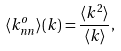Convert formula to latex. <formula><loc_0><loc_0><loc_500><loc_500>\langle k _ { n n } ^ { o } \rangle ( k ) = \frac { \langle k ^ { 2 } \rangle } { \langle k \rangle } ,</formula> 